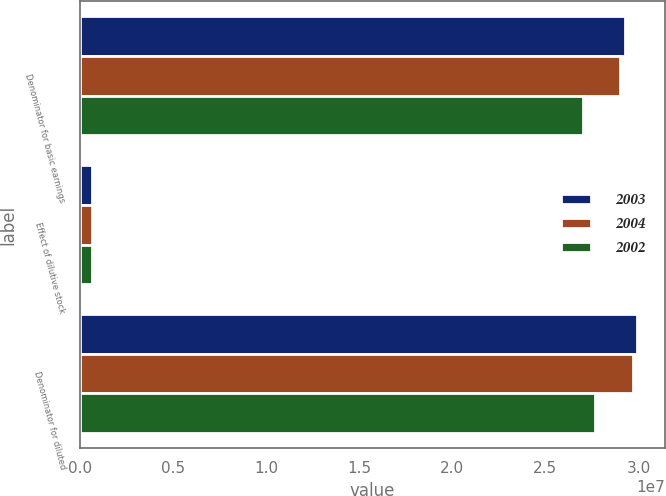<chart> <loc_0><loc_0><loc_500><loc_500><stacked_bar_chart><ecel><fcel>Denominator for basic earnings<fcel>Effect of dilutive stock<fcel>Denominator for diluted<nl><fcel>2003<fcel>2.92791e+07<fcel>633737<fcel>2.99128e+07<nl><fcel>2004<fcel>2.90313e+07<fcel>679564<fcel>2.97109e+07<nl><fcel>2002<fcel>2.70021e+07<fcel>646964<fcel>2.76491e+07<nl></chart> 